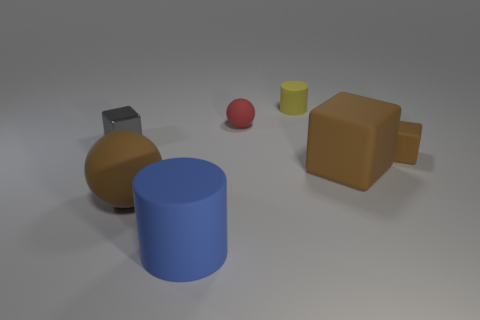Add 2 big brown blocks. How many objects exist? 9 Subtract all blocks. How many objects are left? 4 Subtract all gray metal things. Subtract all red objects. How many objects are left? 5 Add 7 gray blocks. How many gray blocks are left? 8 Add 6 tiny red rubber spheres. How many tiny red rubber spheres exist? 7 Subtract 1 brown balls. How many objects are left? 6 